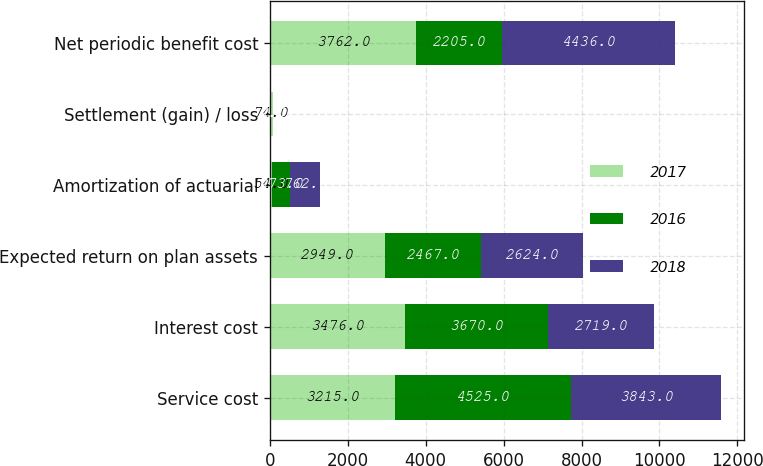<chart> <loc_0><loc_0><loc_500><loc_500><stacked_bar_chart><ecel><fcel>Service cost<fcel>Interest cost<fcel>Expected return on plan assets<fcel>Amortization of actuarial<fcel>Settlement (gain) / loss<fcel>Net periodic benefit cost<nl><fcel>2017<fcel>3215<fcel>3476<fcel>2949<fcel>54<fcel>74<fcel>3762<nl><fcel>2016<fcel>4525<fcel>3670<fcel>2467<fcel>473<fcel>4<fcel>2205<nl><fcel>2018<fcel>3843<fcel>2719<fcel>2624<fcel>762<fcel>2<fcel>4436<nl></chart> 